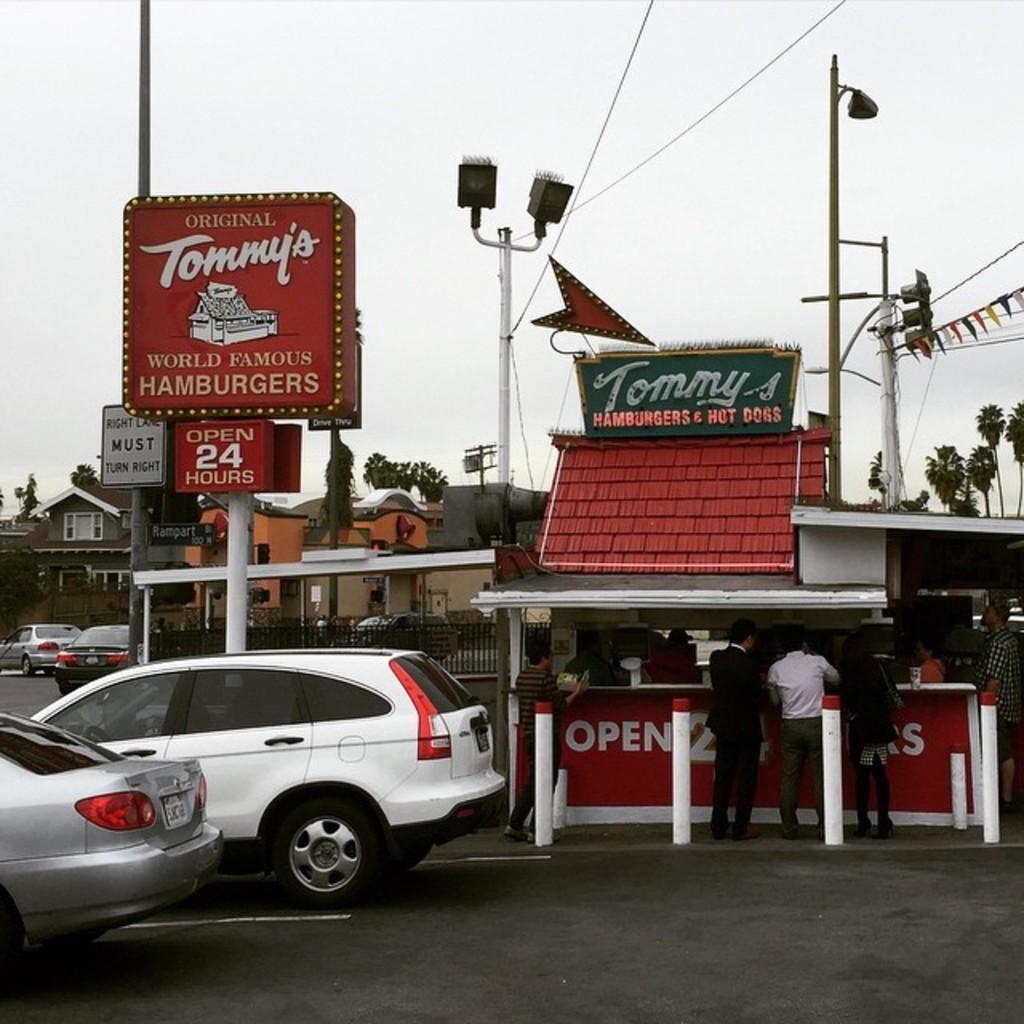How would you summarize this image in a sentence or two? In this picture there is a white color car moving on the road. Behind there is a shop and three persons standing and eating. On the left side there is a red color board on the pole. In the background there are some street poles with cables. 